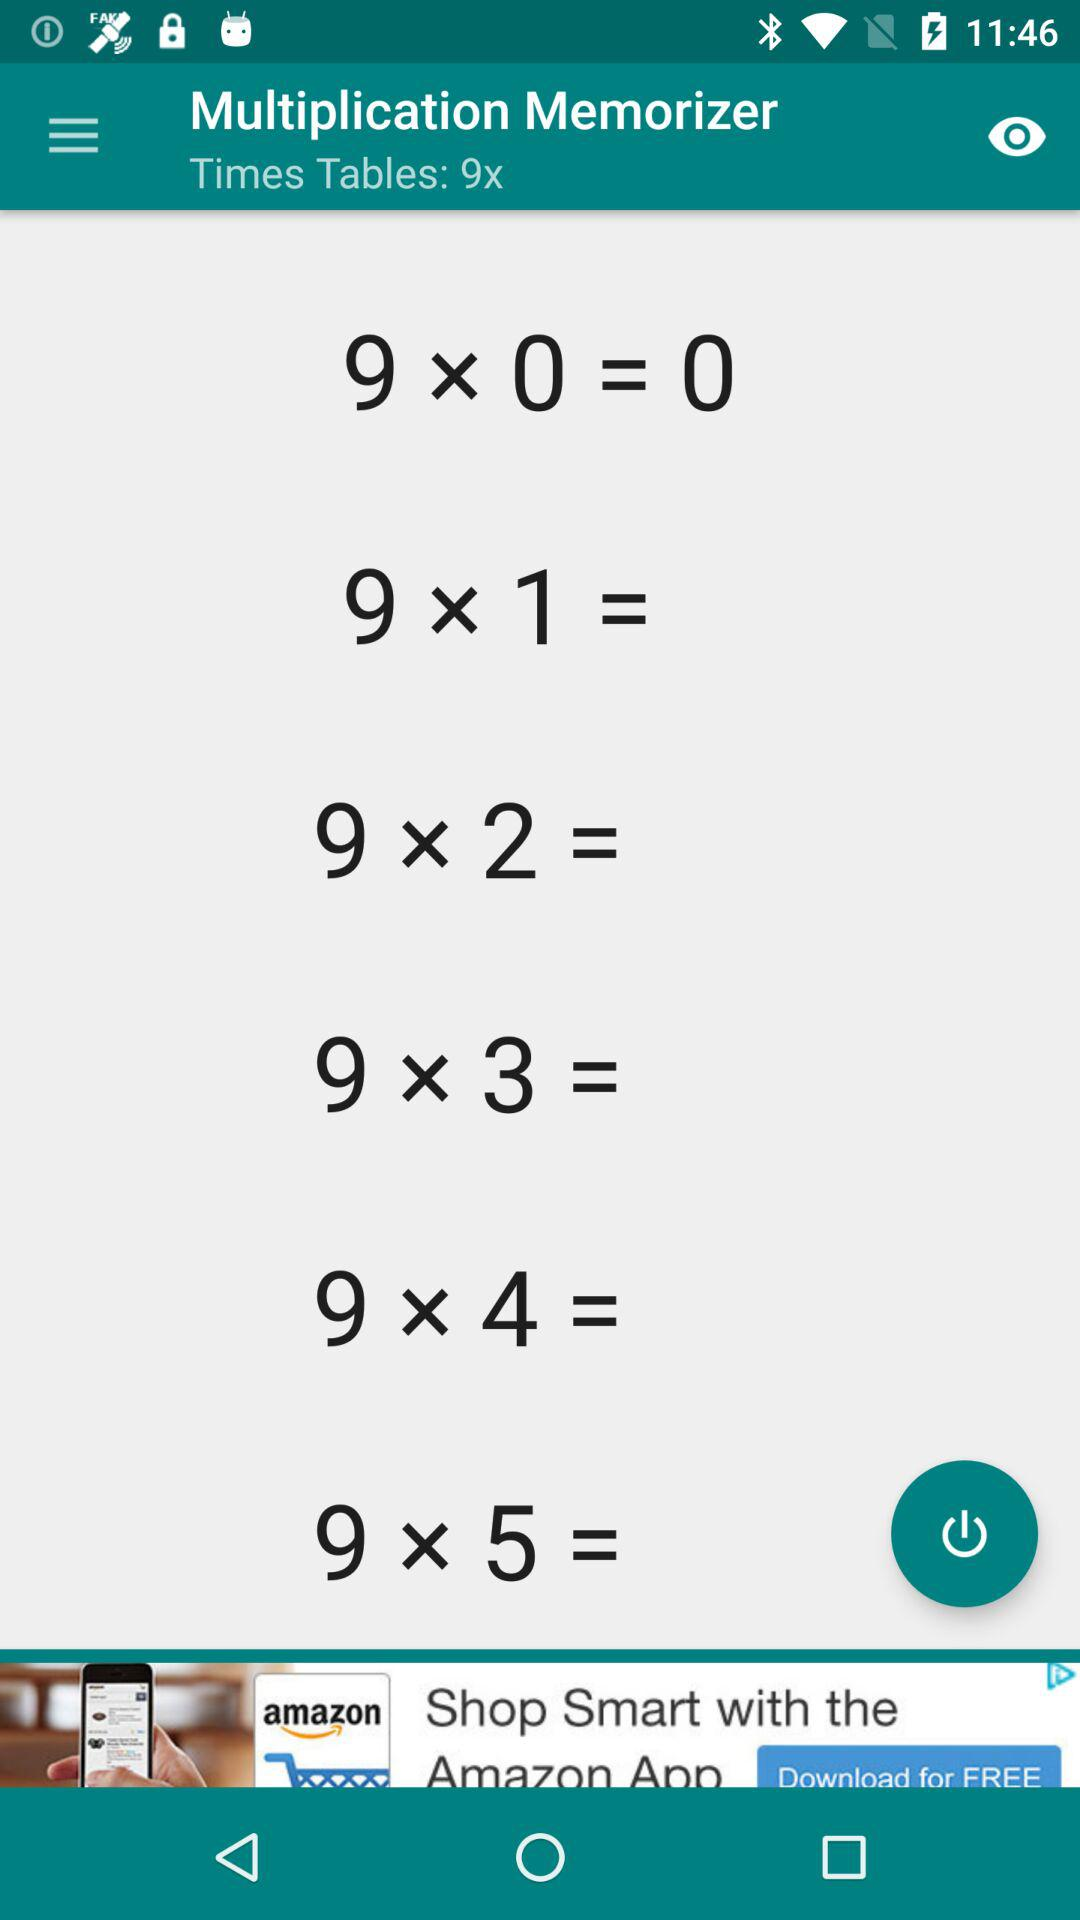How many times tables are displayed?
Answer the question using a single word or phrase. 6 